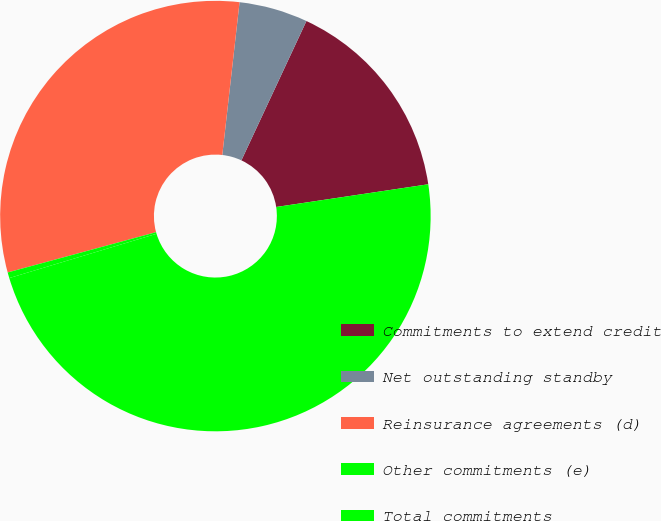Convert chart to OTSL. <chart><loc_0><loc_0><loc_500><loc_500><pie_chart><fcel>Commitments to extend credit<fcel>Net outstanding standby<fcel>Reinsurance agreements (d)<fcel>Other commitments (e)<fcel>Total commitments<nl><fcel>15.69%<fcel>5.16%<fcel>31.01%<fcel>0.43%<fcel>47.71%<nl></chart> 